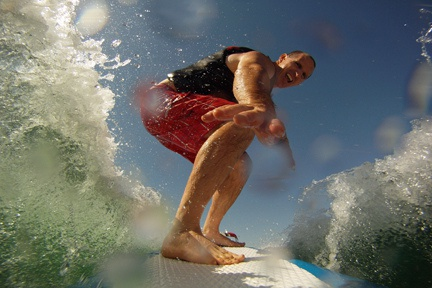Describe the objects in this image and their specific colors. I can see people in gray, maroon, and black tones and surfboard in gray, beige, and darkgray tones in this image. 